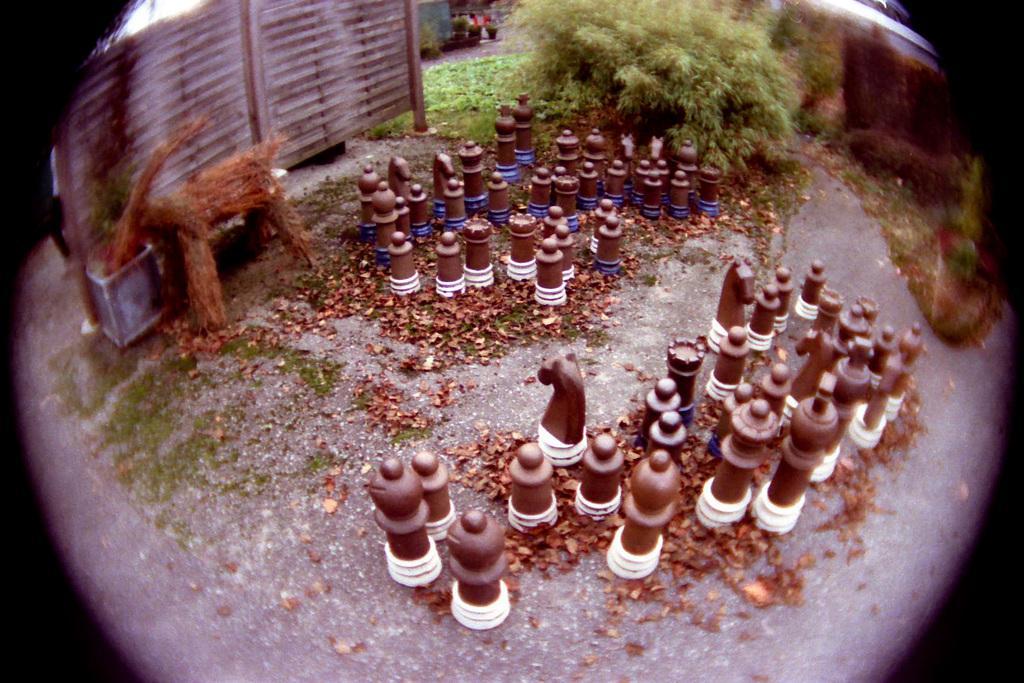Describe this image in one or two sentences. In this image I can see number of brown colour chess coins. I can also see a brown color thing on the top left side and on the top right side I can see bushes and grass. I can also see leaves on the ground. 